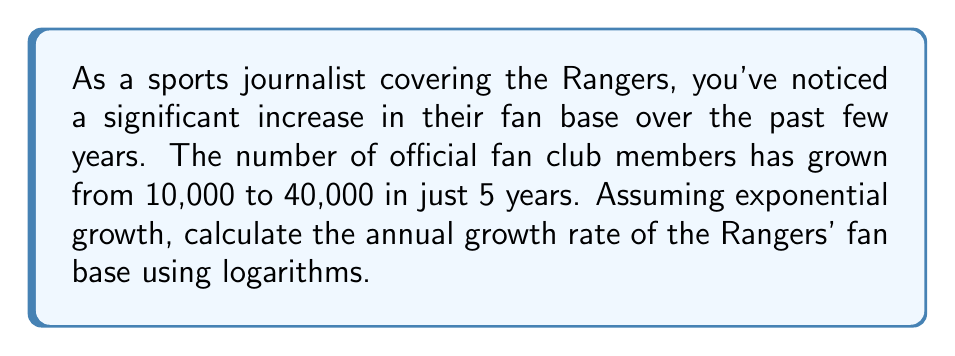Help me with this question. To solve this problem, we'll use the exponential growth formula and logarithms. Let's break it down step by step:

1) The exponential growth formula is:
   $$A = P(1 + r)^t$$
   Where:
   $A$ = Final amount
   $P$ = Initial amount
   $r$ = Annual growth rate (in decimal form)
   $t$ = Time period (in years)

2) We know:
   $P = 10,000$
   $A = 40,000$
   $t = 5$ years

3) Substituting these values into the formula:
   $$40,000 = 10,000(1 + r)^5$$

4) Divide both sides by 10,000:
   $$4 = (1 + r)^5$$

5) To isolate $r$, we need to use logarithms. Let's apply the natural log (ln) to both sides:
   $$\ln(4) = \ln((1 + r)^5)$$

6) Using the logarithm property $\ln(x^n) = n\ln(x)$:
   $$\ln(4) = 5\ln(1 + r)$$

7) Divide both sides by 5:
   $$\frac{\ln(4)}{5} = \ln(1 + r)$$

8) Now, apply $e^x$ to both sides to remove the ln:
   $$e^{\frac{\ln(4)}{5}} = e^{\ln(1 + r)} = 1 + r$$

9) Subtract 1 from both sides:
   $$e^{\frac{\ln(4)}{5}} - 1 = r$$

10) Calculate the value:
    $$r = e^{\frac{\ln(4)}{5}} - 1 \approx 0.3195 \text{ or } 31.95\%$$
Answer: The annual growth rate of the Rangers' fan base is approximately 31.95%. 